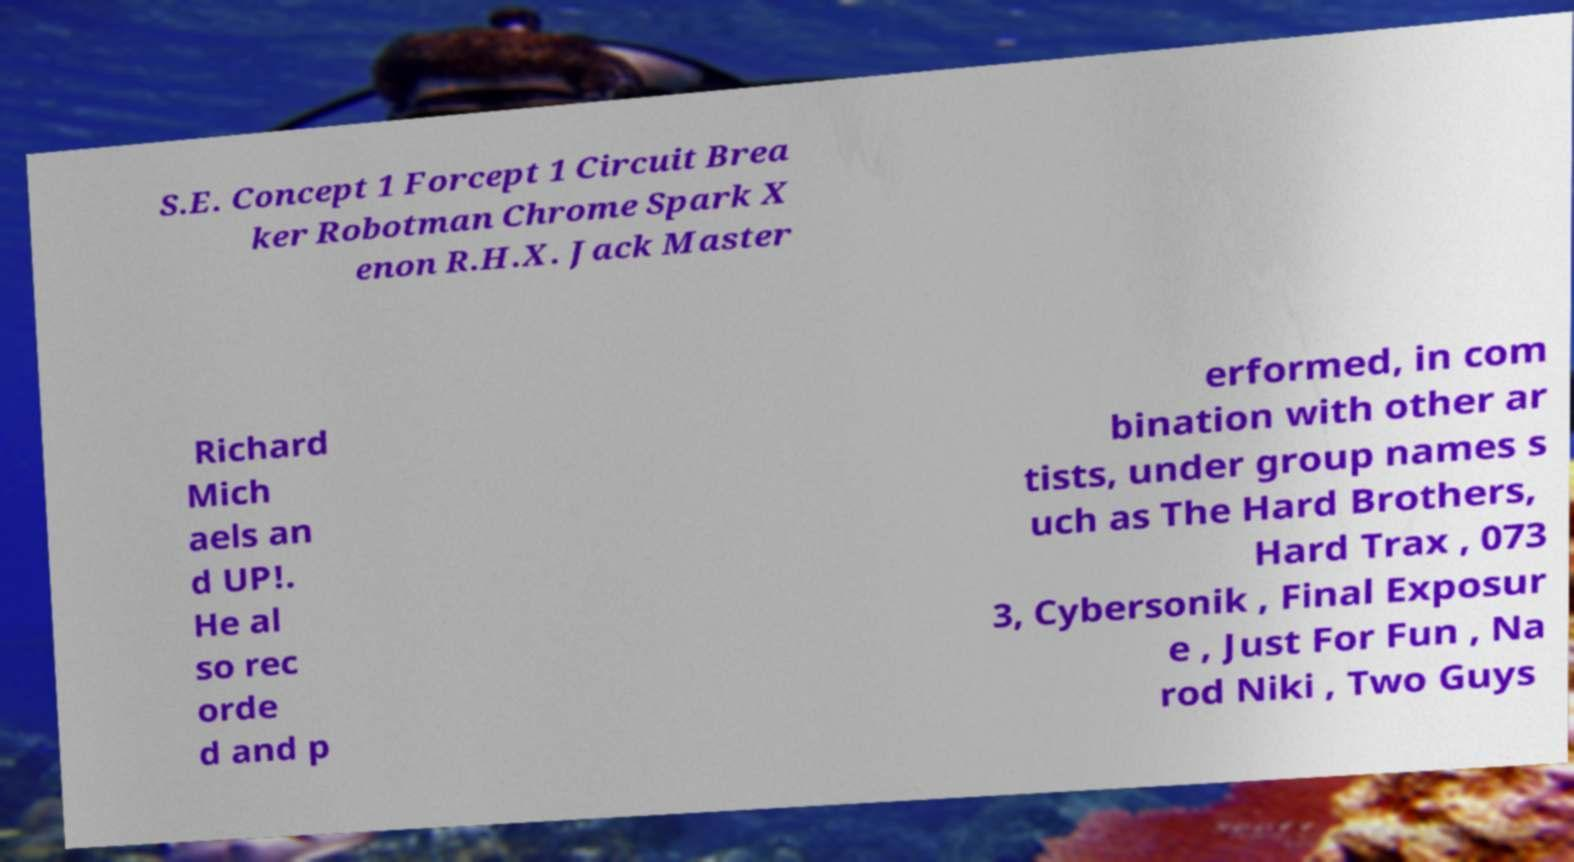Please identify and transcribe the text found in this image. S.E. Concept 1 Forcept 1 Circuit Brea ker Robotman Chrome Spark X enon R.H.X. Jack Master Richard Mich aels an d UP!. He al so rec orde d and p erformed, in com bination with other ar tists, under group names s uch as The Hard Brothers, Hard Trax , 073 3, Cybersonik , Final Exposur e , Just For Fun , Na rod Niki , Two Guys 